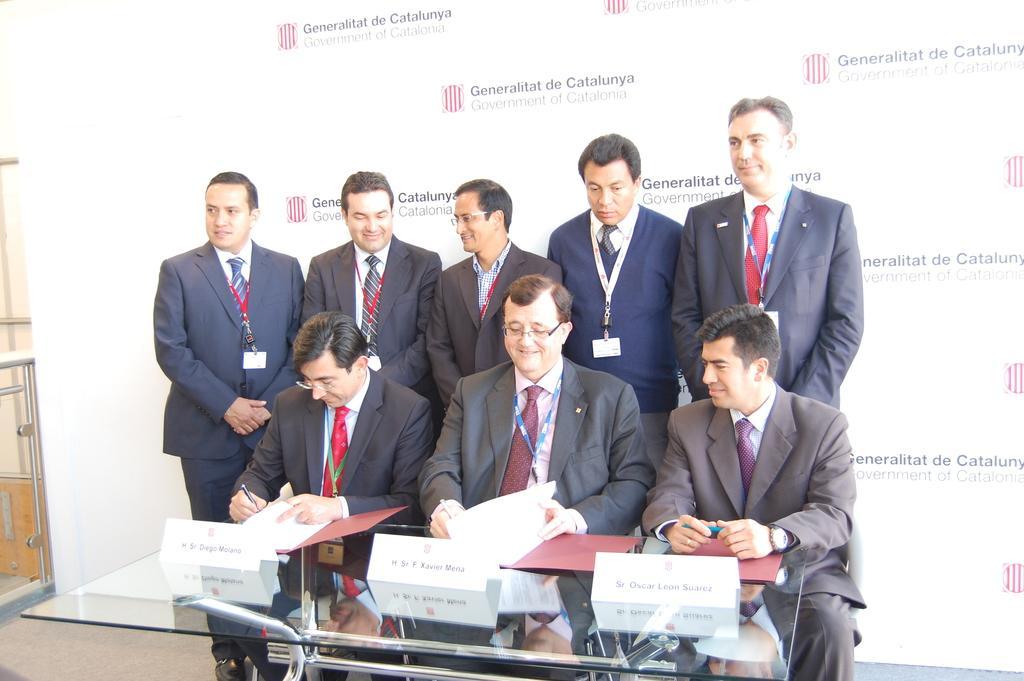In one or two sentences, can you explain what this image depicts? In this image we can see people sitting and some of them are standing. At the bottom there is a table and we can see files and boards placed on the table. In the background there is a board, wall and a door. 